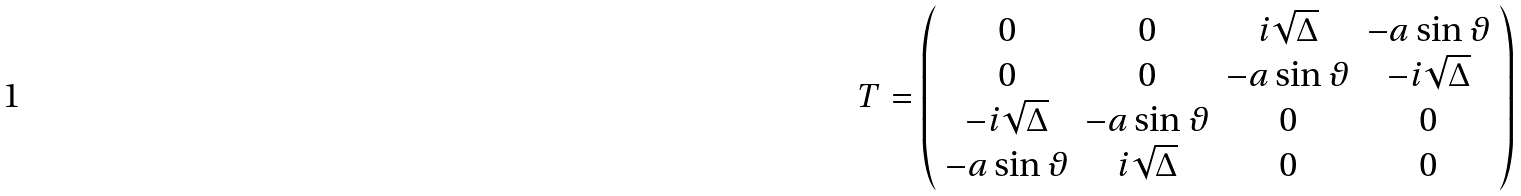<formula> <loc_0><loc_0><loc_500><loc_500>T = \left ( \begin{array} { c c c c } 0 & 0 & i \sqrt { \Delta } & - a \sin { \vartheta } \\ 0 & 0 & - a \sin { \vartheta } & - i \sqrt { \Delta } \\ - i \sqrt { \Delta } & - a \sin { \vartheta } & 0 & 0 \\ - a \sin { \vartheta } & i \sqrt { \Delta } & 0 & 0 \end{array} \right )</formula> 